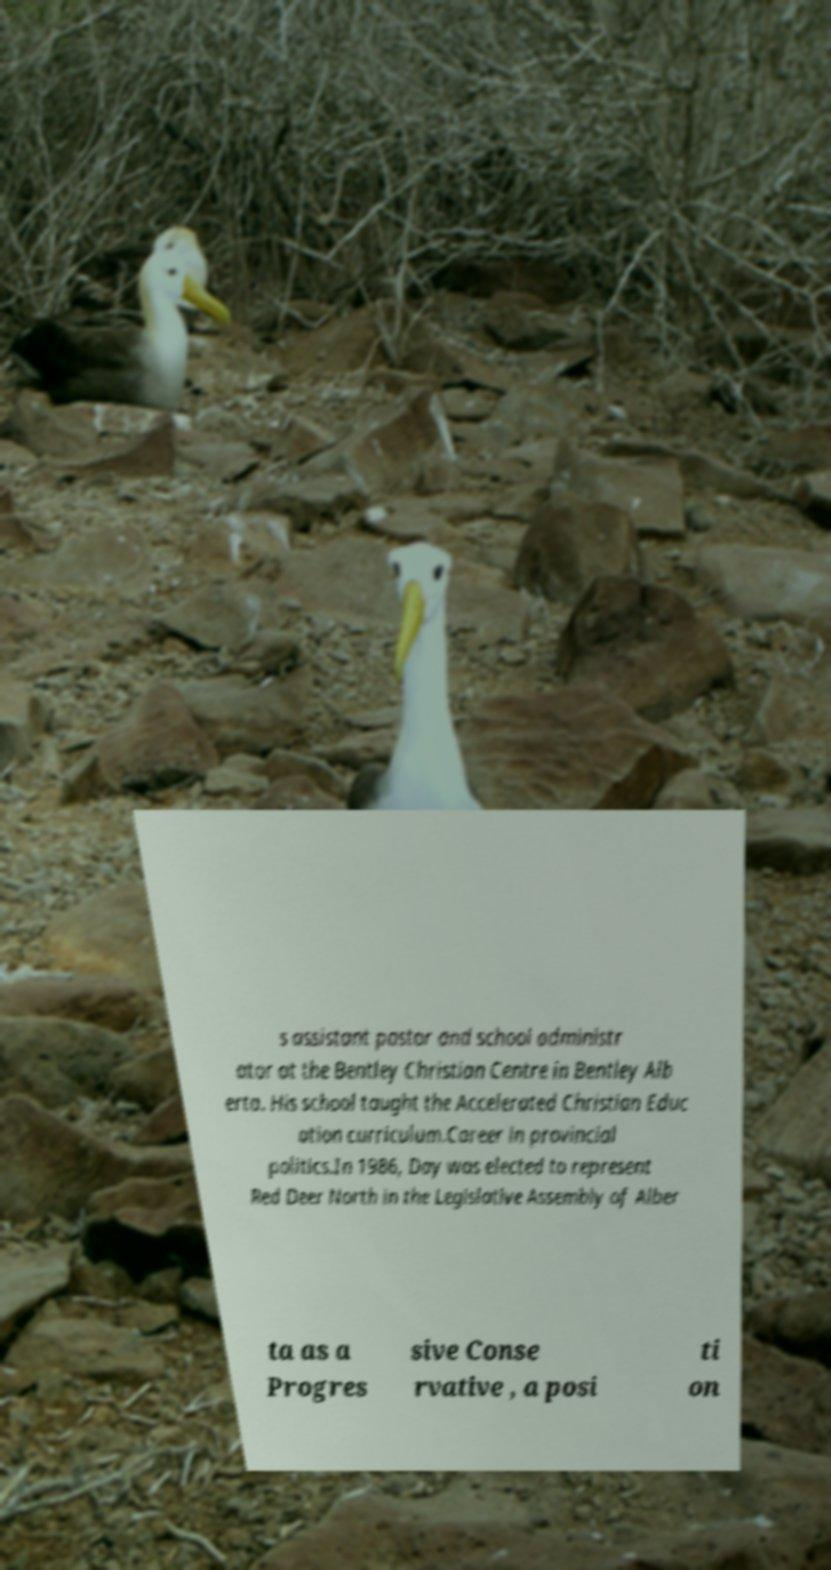Please read and relay the text visible in this image. What does it say? s assistant pastor and school administr ator at the Bentley Christian Centre in Bentley Alb erta. His school taught the Accelerated Christian Educ ation curriculum.Career in provincial politics.In 1986, Day was elected to represent Red Deer North in the Legislative Assembly of Alber ta as a Progres sive Conse rvative , a posi ti on 